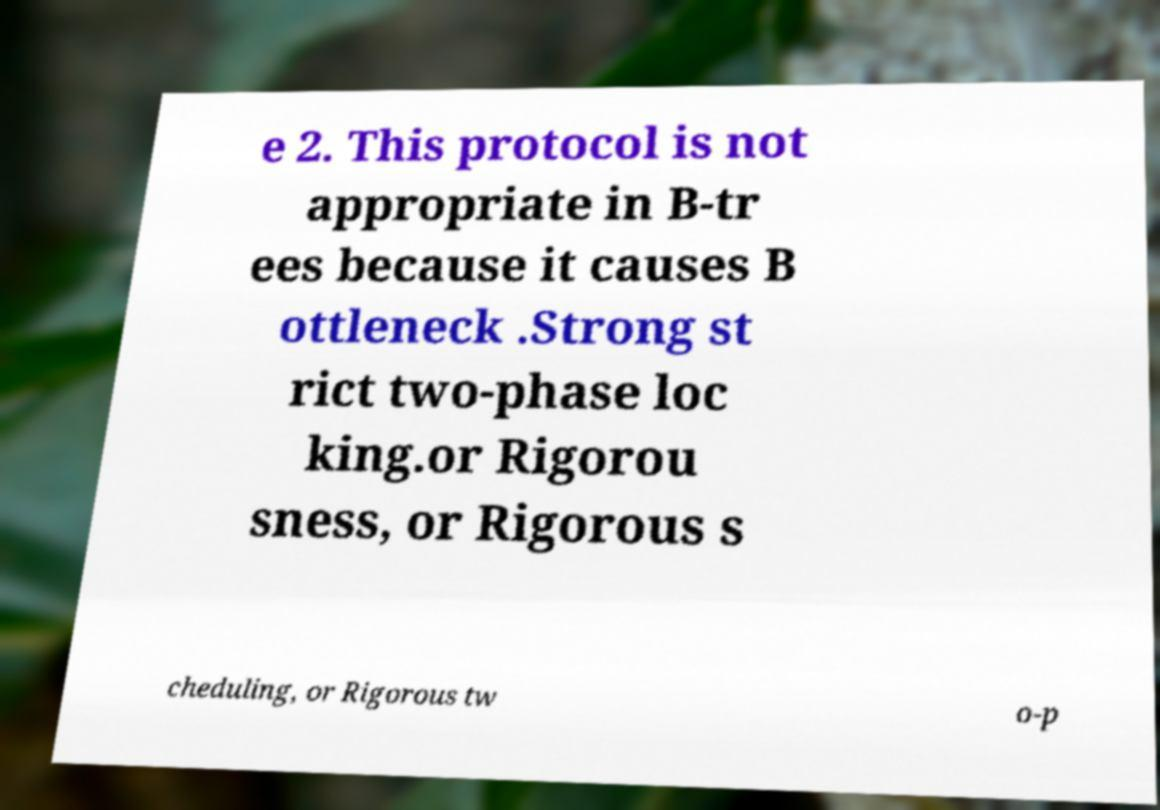What messages or text are displayed in this image? I need them in a readable, typed format. e 2. This protocol is not appropriate in B-tr ees because it causes B ottleneck .Strong st rict two-phase loc king.or Rigorou sness, or Rigorous s cheduling, or Rigorous tw o-p 